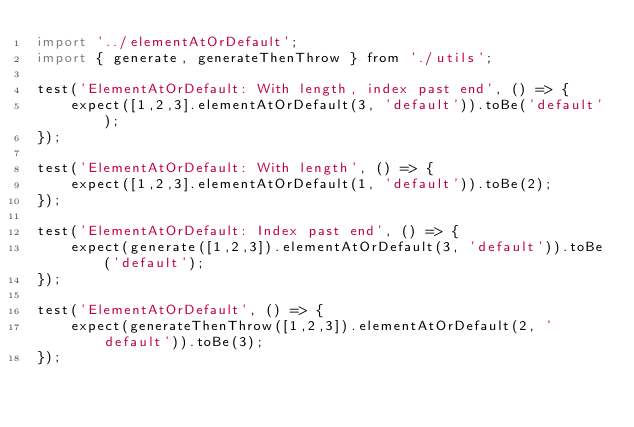Convert code to text. <code><loc_0><loc_0><loc_500><loc_500><_JavaScript_>import '../elementAtOrDefault';
import { generate, generateThenThrow } from './utils';

test('ElementAtOrDefault: With length, index past end', () => {
    expect([1,2,3].elementAtOrDefault(3, 'default')).toBe('default');
});

test('ElementAtOrDefault: With length', () => {
    expect([1,2,3].elementAtOrDefault(1, 'default')).toBe(2);
});

test('ElementAtOrDefault: Index past end', () => {
    expect(generate([1,2,3]).elementAtOrDefault(3, 'default')).toBe('default');
});

test('ElementAtOrDefault', () => {
    expect(generateThenThrow([1,2,3]).elementAtOrDefault(2, 'default')).toBe(3);
});
</code> 